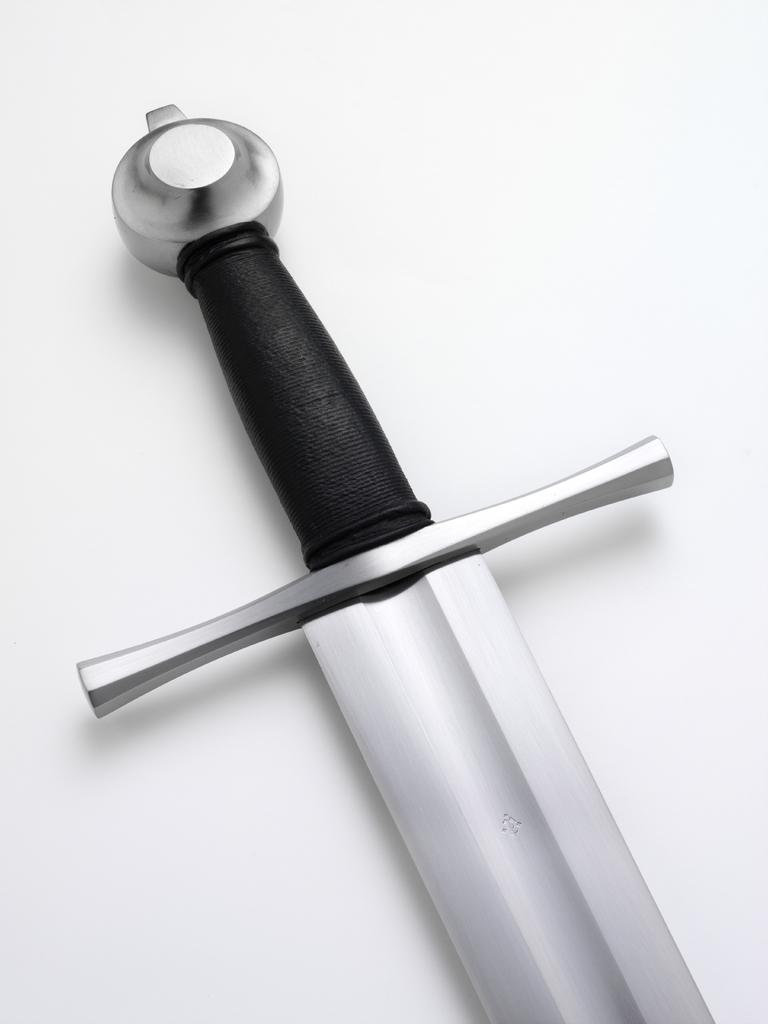What weapon is present in the image? There is a sword in the image. What part of the sword has a specific color? The sword has a black color handle. How many prisoners are visible in the image? There are no prisoners present in the image; it only features a sword with a black handle. What type of snake can be seen wrapped around the sword in the image? There is no snake present in the image; it only features a sword with a black handle. 